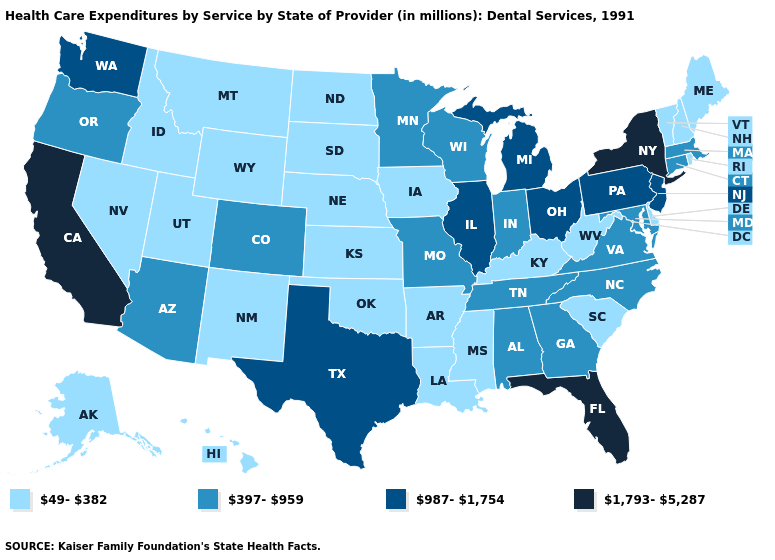What is the highest value in the MidWest ?
Quick response, please. 987-1,754. What is the value of Mississippi?
Answer briefly. 49-382. Does the map have missing data?
Answer briefly. No. What is the lowest value in the South?
Keep it brief. 49-382. How many symbols are there in the legend?
Quick response, please. 4. What is the highest value in the West ?
Answer briefly. 1,793-5,287. Name the states that have a value in the range 987-1,754?
Give a very brief answer. Illinois, Michigan, New Jersey, Ohio, Pennsylvania, Texas, Washington. Name the states that have a value in the range 397-959?
Write a very short answer. Alabama, Arizona, Colorado, Connecticut, Georgia, Indiana, Maryland, Massachusetts, Minnesota, Missouri, North Carolina, Oregon, Tennessee, Virginia, Wisconsin. What is the lowest value in the USA?
Answer briefly. 49-382. Does Montana have the highest value in the USA?
Quick response, please. No. Name the states that have a value in the range 987-1,754?
Concise answer only. Illinois, Michigan, New Jersey, Ohio, Pennsylvania, Texas, Washington. Which states have the highest value in the USA?
Be succinct. California, Florida, New York. Does the map have missing data?
Give a very brief answer. No. Name the states that have a value in the range 397-959?
Answer briefly. Alabama, Arizona, Colorado, Connecticut, Georgia, Indiana, Maryland, Massachusetts, Minnesota, Missouri, North Carolina, Oregon, Tennessee, Virginia, Wisconsin. What is the lowest value in states that border Rhode Island?
Be succinct. 397-959. 